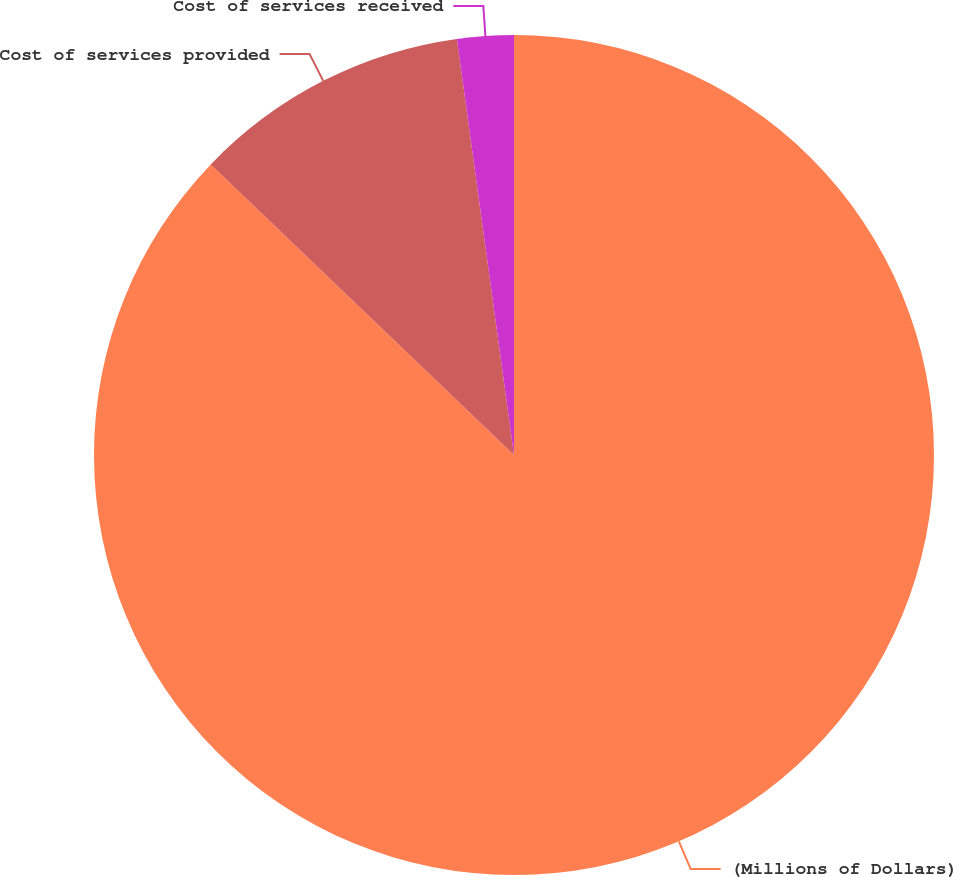<chart> <loc_0><loc_0><loc_500><loc_500><pie_chart><fcel>(Millions of Dollars)<fcel>Cost of services provided<fcel>Cost of services received<nl><fcel>87.16%<fcel>10.67%<fcel>2.17%<nl></chart> 